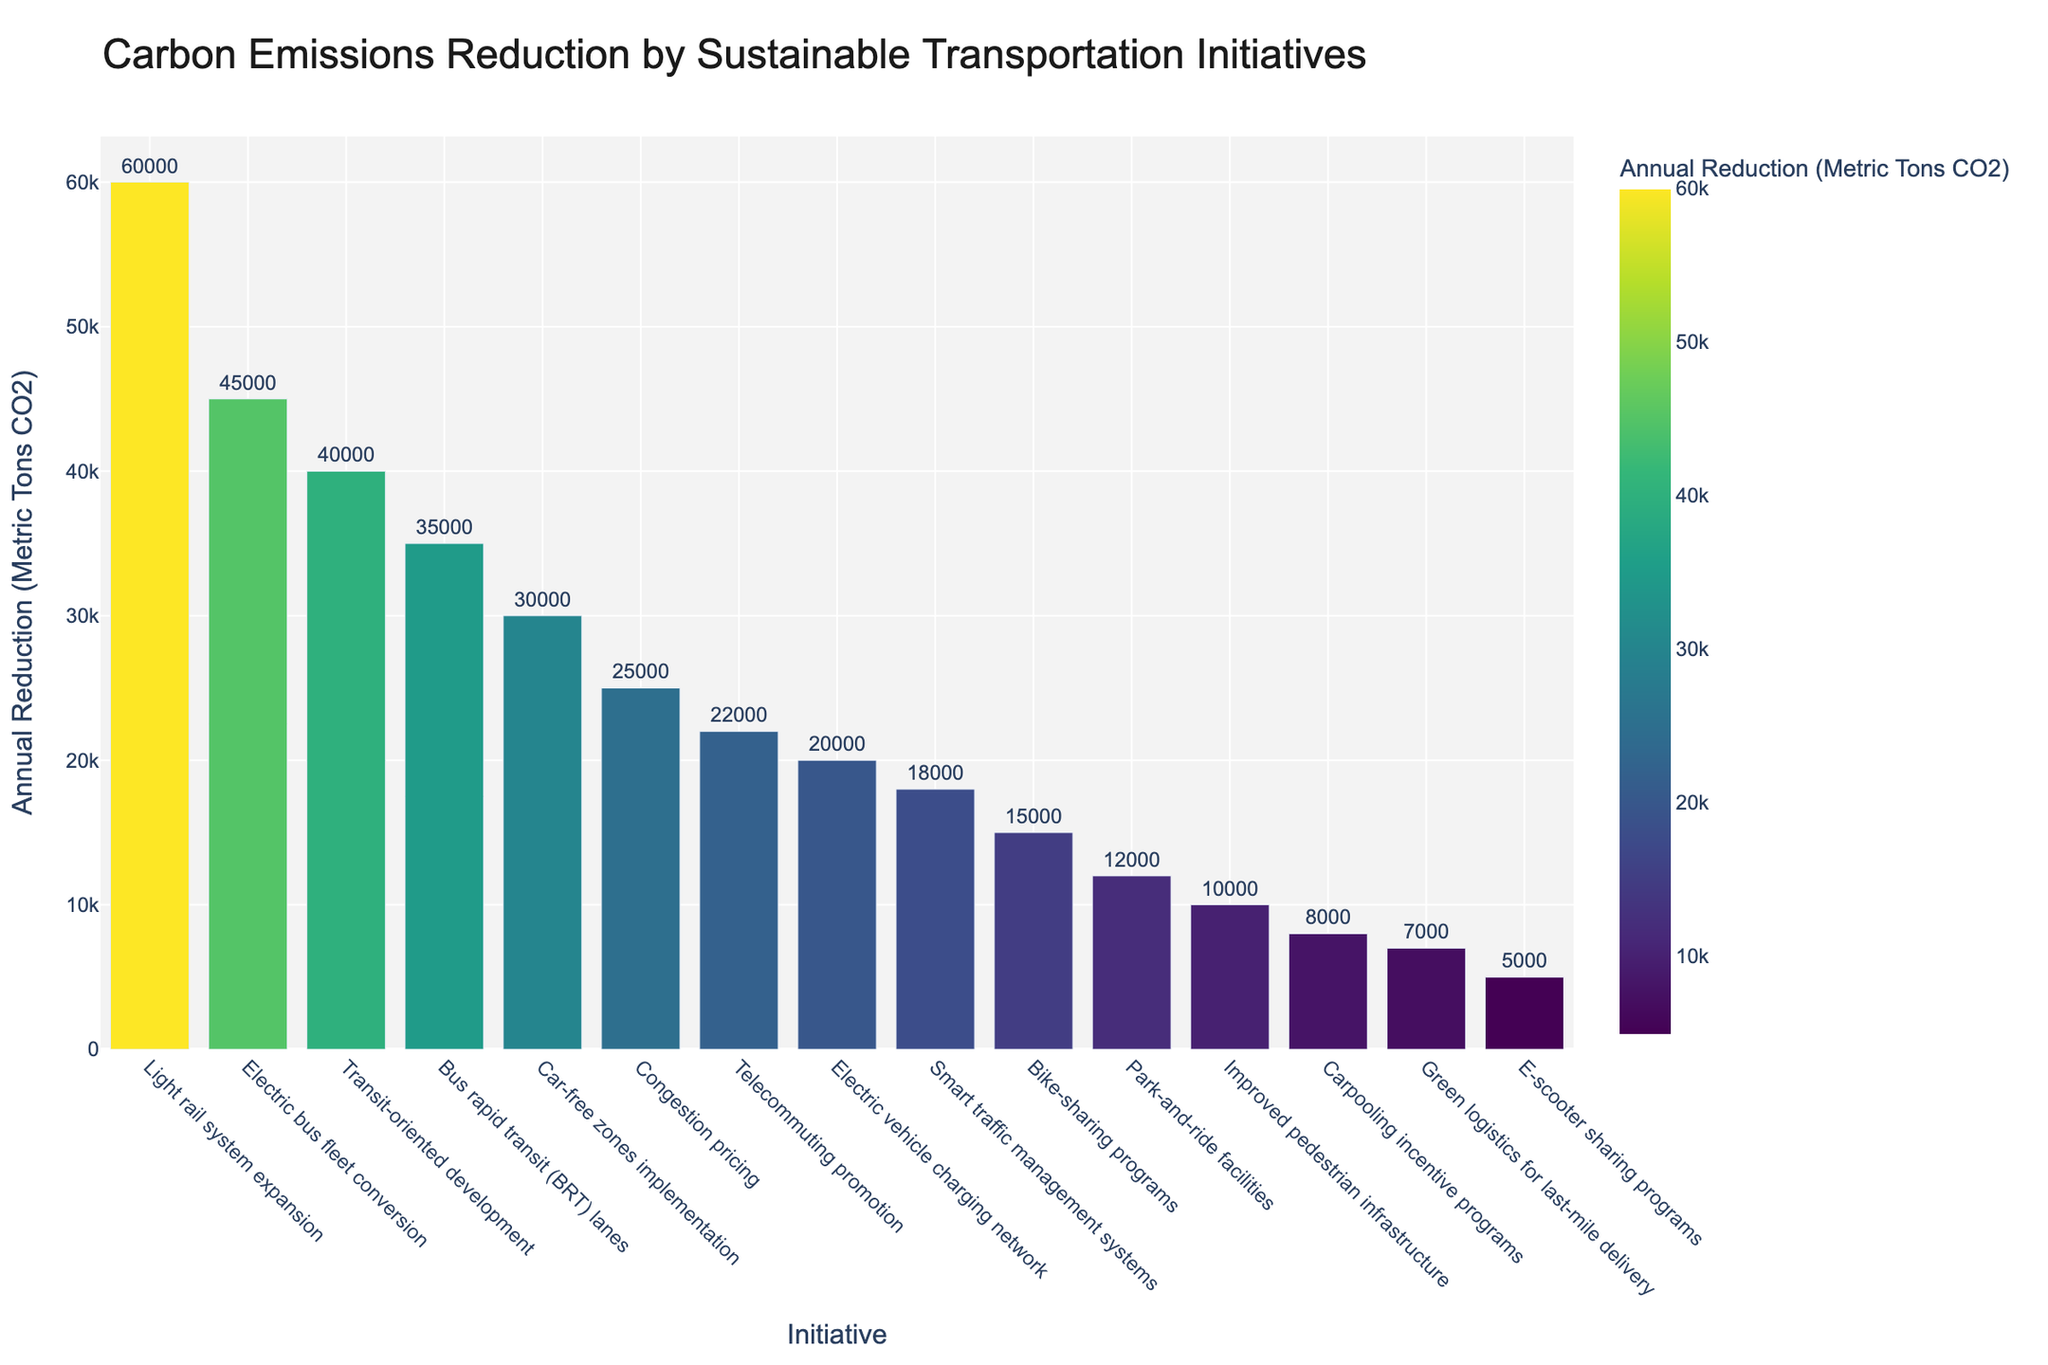Which initiative achieved the highest annual carbon emissions reduction? The bar representing "Light rail system expansion" is the tallest among all the bars, indicating it achieved the highest annual carbon emissions reduction.
Answer: Light rail system expansion What is the total annual carbon emissions reduction achieved by "Bike-sharing programs" and "Electric vehicle charging network"? The bar for "Bike-sharing programs" shows a reduction of 15,000 metric tons, and the bar for "Electric vehicle charging network" shows a reduction of 20,000 metric tons. Adding these values gives 15,000 + 20,000 = 35,000 metric tons.
Answer: 35,000 metric tons Which initiative achieved a higher annual reduction: "Congestion pricing" or "Bus rapid transit (BRT) lanes"? The bar for "Bus rapid transit (BRT) lanes" indicates a reduction of 35,000 metric tons, while the bar for "Congestion pricing" indicates a reduction of 25,000 metric tons. Therefore, "Bus rapid transit (BRT) lanes" achieved a higher reduction.
Answer: Bus rapid transit (BRT) lanes How much more carbon emissions does "Light rail system expansion" reduce compared to "Carpooling incentive programs"? The annual reduction for "Light rail system expansion" is shown as 60,000 metric tons, and for "Carpooling incentive programs" it is 8,000 metric tons. The difference is 60,000 - 8,000 = 52,000 metric tons.
Answer: 52,000 metric tons What is the median value of the annual carbon emissions reductions presented in the chart? Sorting the reductions: 5,000, 7,000, 8,000, 10,000, 12,000, 15,000, 18,000, 20,000, 22,000, 25,000, 30,000, 35,000, 40,000, 45,000, 60,000. The median is the middle value, which is the 8th value in this sorted list (20,000).
Answer: 20,000 metric tons What is the combined annual carbon emissions reduction of the top three initiatives? The top three bars represent "Light rail system expansion" (60,000 metric tons), "Electric bus fleet conversion" (45,000 metric tons), and "Transit-oriented development" (40,000 metric tons). Adding these values: 60,000 + 45,000 + 40,000 = 145,000 metric tons.
Answer: 145,000 metric tons Which initiative has the shortest bar? The shortest bar represents "E-scooter sharing programs," indicating the lowest annual carbon emissions reduction achieved.
Answer: E-scooter sharing programs How many initiatives achieve an annual reduction of at least 30,000 metric tons? Scan the bars to count those reaching or exceeding the 30,000 metric ton mark. Initiatives: "Light rail system expansion," "Electric bus fleet conversion," "Transit-oriented development," "Bus rapid transit (BRT) lanes," and "Car-free zones implementation" meet this criterion. There are 5 such initiatives.
Answer: 5 initiatives Compare the total annual reductions achieved by "Telecommuting promotion" and "Smart traffic management systems" combined and "Car-free zones implementation.” Which is higher? "Telecommuting promotion" achieves 22,000 metric tons, and "Smart traffic management systems" achieves 18,000 metric tons. Combined: 22,000 + 18,000 = 40,000 metric tons. "Car-free zones implementation" achieves 30,000 metric tons. Therefore, 40,000 metric tons is higher than 30,000 metric tons.
Answer: Combined total is higher 